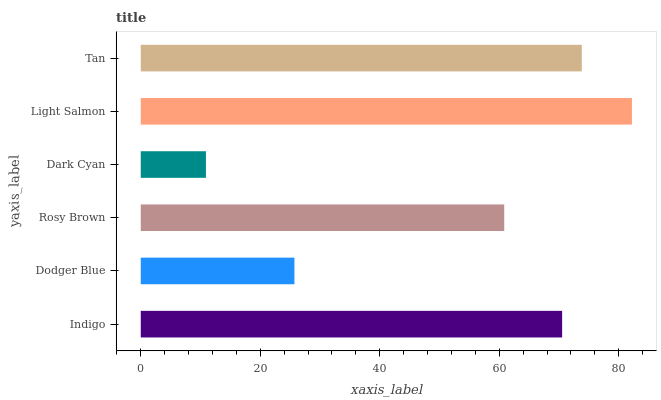Is Dark Cyan the minimum?
Answer yes or no. Yes. Is Light Salmon the maximum?
Answer yes or no. Yes. Is Dodger Blue the minimum?
Answer yes or no. No. Is Dodger Blue the maximum?
Answer yes or no. No. Is Indigo greater than Dodger Blue?
Answer yes or no. Yes. Is Dodger Blue less than Indigo?
Answer yes or no. Yes. Is Dodger Blue greater than Indigo?
Answer yes or no. No. Is Indigo less than Dodger Blue?
Answer yes or no. No. Is Indigo the high median?
Answer yes or no. Yes. Is Rosy Brown the low median?
Answer yes or no. Yes. Is Dark Cyan the high median?
Answer yes or no. No. Is Indigo the low median?
Answer yes or no. No. 